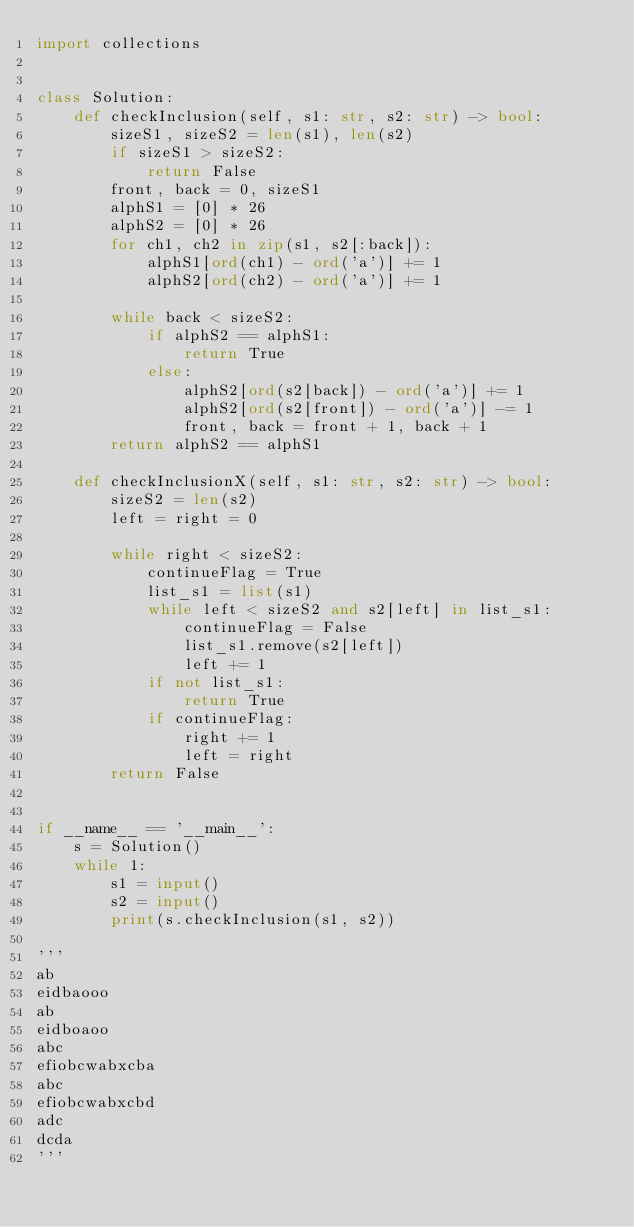Convert code to text. <code><loc_0><loc_0><loc_500><loc_500><_Python_>import collections


class Solution:
    def checkInclusion(self, s1: str, s2: str) -> bool:
        sizeS1, sizeS2 = len(s1), len(s2)
        if sizeS1 > sizeS2:
            return False
        front, back = 0, sizeS1
        alphS1 = [0] * 26
        alphS2 = [0] * 26
        for ch1, ch2 in zip(s1, s2[:back]):
            alphS1[ord(ch1) - ord('a')] += 1
            alphS2[ord(ch2) - ord('a')] += 1

        while back < sizeS2:
            if alphS2 == alphS1:
                return True
            else:
                alphS2[ord(s2[back]) - ord('a')] += 1
                alphS2[ord(s2[front]) - ord('a')] -= 1
                front, back = front + 1, back + 1
        return alphS2 == alphS1

    def checkInclusionX(self, s1: str, s2: str) -> bool:
        sizeS2 = len(s2)
        left = right = 0

        while right < sizeS2:
            continueFlag = True
            list_s1 = list(s1)
            while left < sizeS2 and s2[left] in list_s1:
                continueFlag = False
                list_s1.remove(s2[left])
                left += 1
            if not list_s1:
                return True
            if continueFlag:
                right += 1
                left = right
        return False


if __name__ == '__main__':
    s = Solution()
    while 1:
        s1 = input()
        s2 = input()
        print(s.checkInclusion(s1, s2))

'''
ab
eidbaooo
ab
eidboaoo
abc
efiobcwabxcba
abc
efiobcwabxcbd
adc
dcda
'''
</code> 